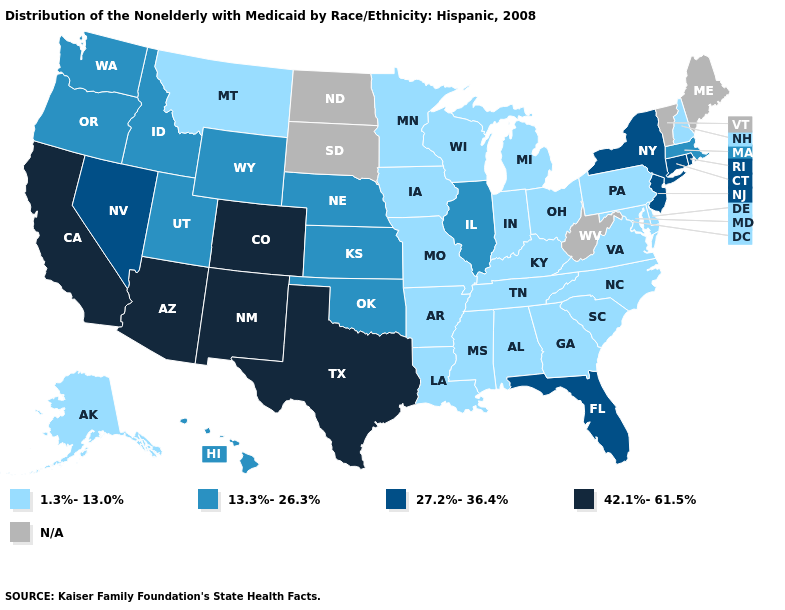What is the highest value in the USA?
Concise answer only. 42.1%-61.5%. What is the lowest value in the Northeast?
Concise answer only. 1.3%-13.0%. Among the states that border California , does Arizona have the lowest value?
Answer briefly. No. Among the states that border New Jersey , which have the highest value?
Short answer required. New York. What is the value of Michigan?
Short answer required. 1.3%-13.0%. Among the states that border Delaware , does New Jersey have the lowest value?
Quick response, please. No. What is the lowest value in the USA?
Keep it brief. 1.3%-13.0%. Which states have the lowest value in the USA?
Keep it brief. Alabama, Alaska, Arkansas, Delaware, Georgia, Indiana, Iowa, Kentucky, Louisiana, Maryland, Michigan, Minnesota, Mississippi, Missouri, Montana, New Hampshire, North Carolina, Ohio, Pennsylvania, South Carolina, Tennessee, Virginia, Wisconsin. Which states have the lowest value in the USA?
Be succinct. Alabama, Alaska, Arkansas, Delaware, Georgia, Indiana, Iowa, Kentucky, Louisiana, Maryland, Michigan, Minnesota, Mississippi, Missouri, Montana, New Hampshire, North Carolina, Ohio, Pennsylvania, South Carolina, Tennessee, Virginia, Wisconsin. Name the states that have a value in the range 13.3%-26.3%?
Give a very brief answer. Hawaii, Idaho, Illinois, Kansas, Massachusetts, Nebraska, Oklahoma, Oregon, Utah, Washington, Wyoming. Name the states that have a value in the range 13.3%-26.3%?
Write a very short answer. Hawaii, Idaho, Illinois, Kansas, Massachusetts, Nebraska, Oklahoma, Oregon, Utah, Washington, Wyoming. Among the states that border Montana , which have the highest value?
Answer briefly. Idaho, Wyoming. What is the value of West Virginia?
Answer briefly. N/A. 